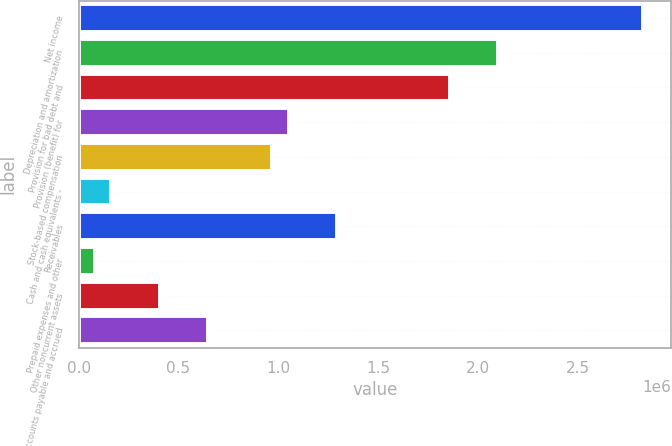Convert chart. <chart><loc_0><loc_0><loc_500><loc_500><bar_chart><fcel>Net income<fcel>Depreciation and amortization<fcel>Provision for bad debt and<fcel>Provision (benefit) for<fcel>Stock-based compensation<fcel>Cash and cash equivalents -<fcel>Receivables<fcel>Prepaid expenses and other<fcel>Other noncurrent assets<fcel>Accounts payable and accrued<nl><fcel>2.82813e+06<fcel>2.10145e+06<fcel>1.85923e+06<fcel>1.05181e+06<fcel>971065<fcel>163646<fcel>1.29403e+06<fcel>82903.9<fcel>405872<fcel>648097<nl></chart> 